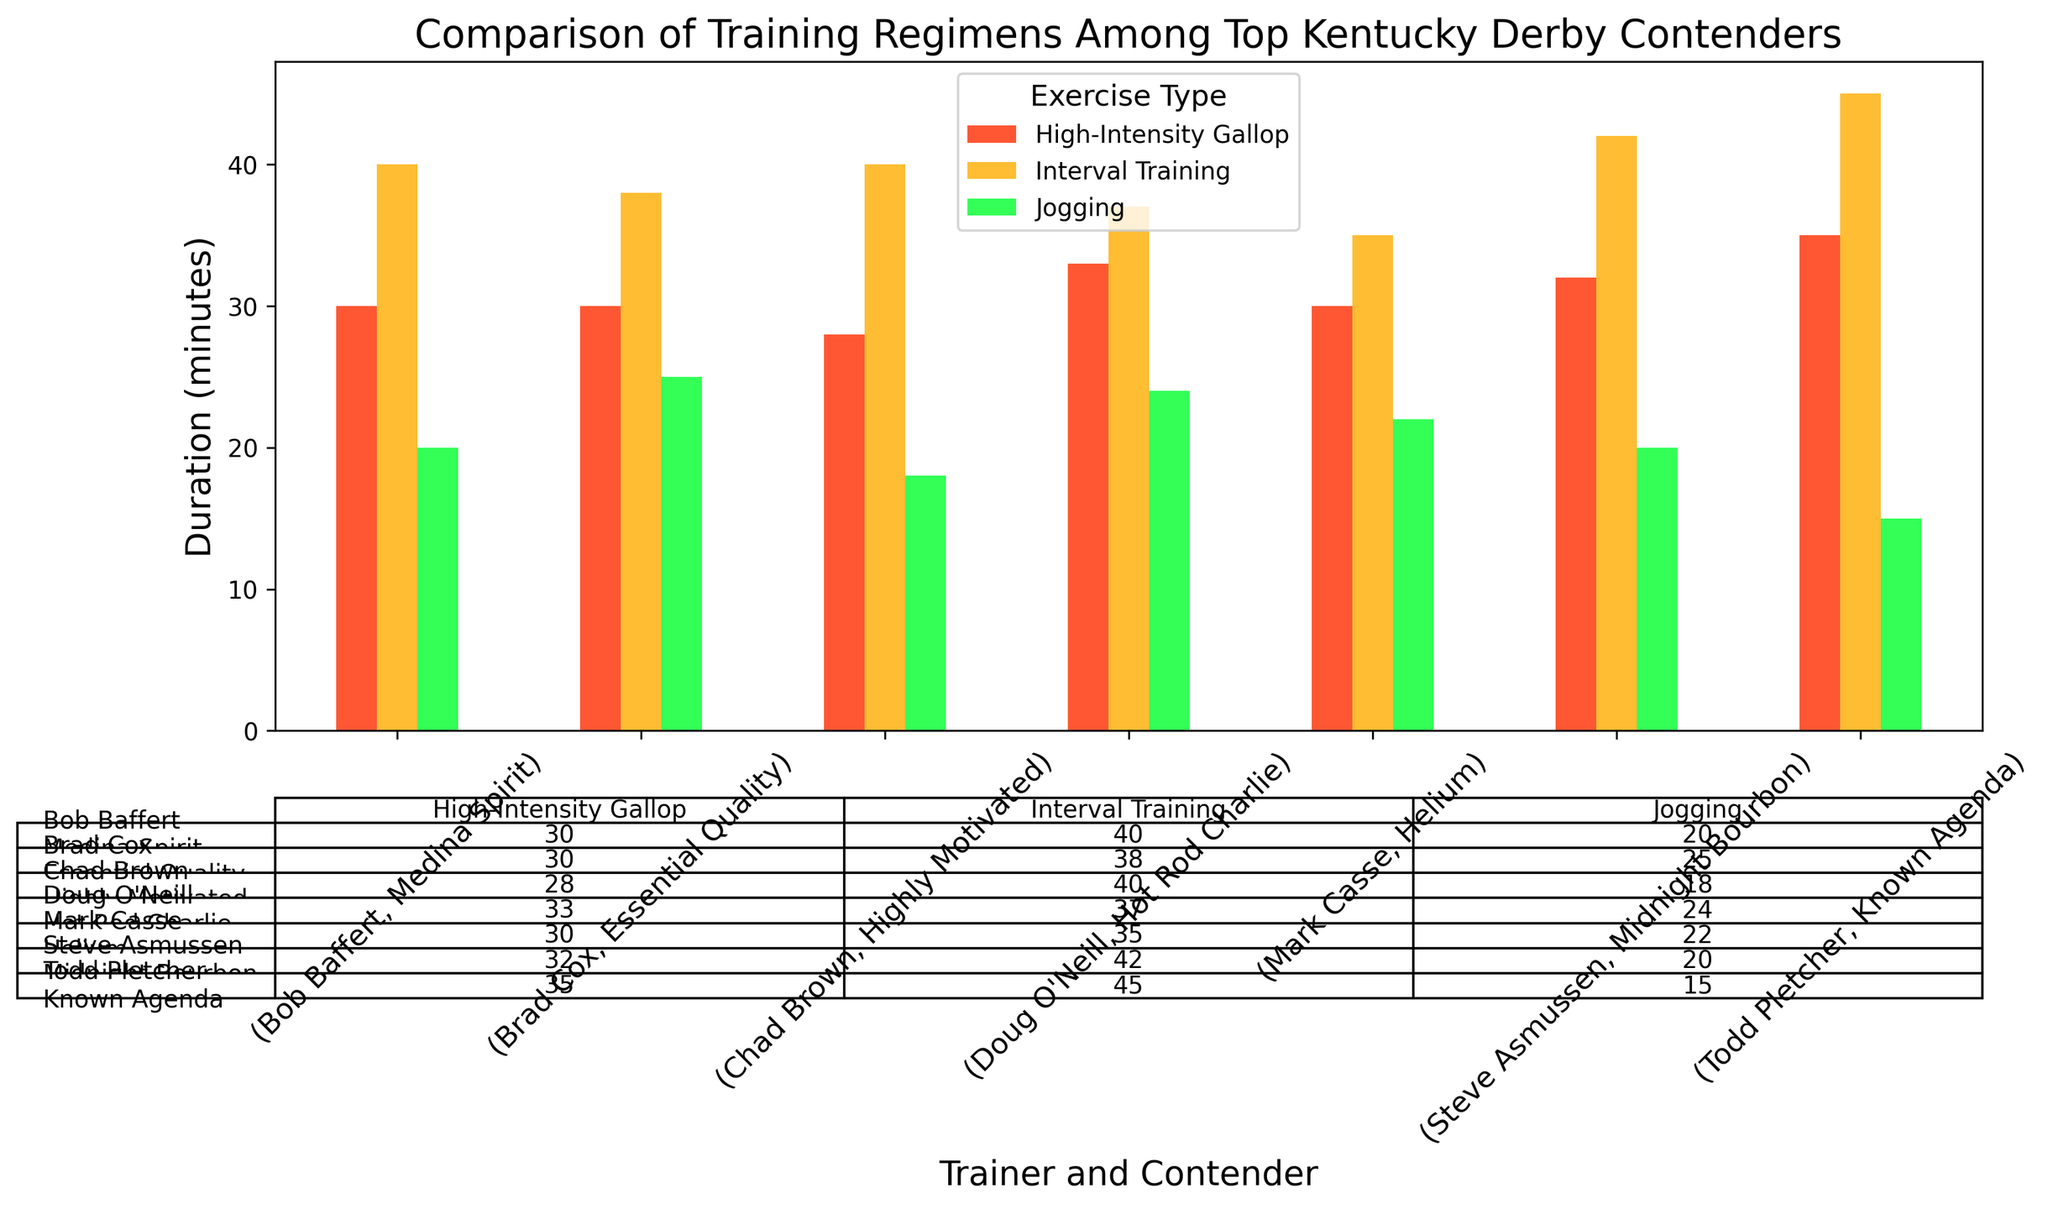Which trainer has the contender with the longest total training duration? Sum the durations of each exercise type for each contender, and compare the sums. Todd Pletcher's Known Agenda has a total duration of 15 + 35 + 45 = 95 minutes, which is the longest.
Answer: Todd Pletcher Which contender has the shortest duration of high-intensity gallop? Compare the durations of high-intensity gallop across all contenders. Chad Brown's Highly Motivated has the shortest duration with 28 minutes.
Answer: Highly Motivated What is the average duration of interval training across all contenders? Calculate the duration sums of interval training (40 + 45 + 38 + 42 + 40 + 35 + 37 = 277) and divide by the number of contenders (7). 277 / 7 = 39.57 minutes.
Answer: 39.57 minutes Which exercise type has the most consistent (least varied) durations among the contenders? Observe the range of durations for each exercise type. Jogging has durations ranging from 15 to 25 minutes (a 10-minute range), high-intensity gallop from 28 to 35 minutes (a 7-minute range), and interval training from 35 to 45 minutes (a 10-minute range). High-intensity gallop has the least variation.
Answer: High-intensity gallop Who trains the contender with the lowest overall exercise duration? Sum the durations for each trainer's contender and compare. Steve Asmussen's Midnight Bourbon has a total of 20 + 32 + 42 = 94 minutes, which is the lowest overall.
Answer: Steve Asmussen How many trainers have at least one contender performing more than 30 minutes of high-intensity gallop? Count the contenders that perform more than 30 minutes of high-intensity gallop and their related trainers. Four contenders (Medina Spirit, Known Agenda, Midnight Bourbon, Hot Rod Charlie) from four different trainers (Bob Baffert, Todd Pletcher, Steve Asmussen, Doug O'Neill) meet this criteria.
Answer: 4 trainers Which contender spends the most time jogging? Compare the jogging durations across all contenders. Brad Cox's Essential Quality jogs for 25 minutes, which is the longest duration.
Answer: Essential Quality What is the difference in total training durations between the contender with the highest and the contender with the lowest total durations? Compare the total durations of Known Agenda (95 minutes) and Midnight Bourbon (94 minutes) to find their difference. The difference is 95 - 94 = 1 minute.
Answer: 1 minute 